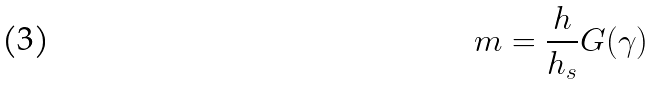<formula> <loc_0><loc_0><loc_500><loc_500>m = \frac { h } { h _ { s } } G ( \gamma )</formula> 